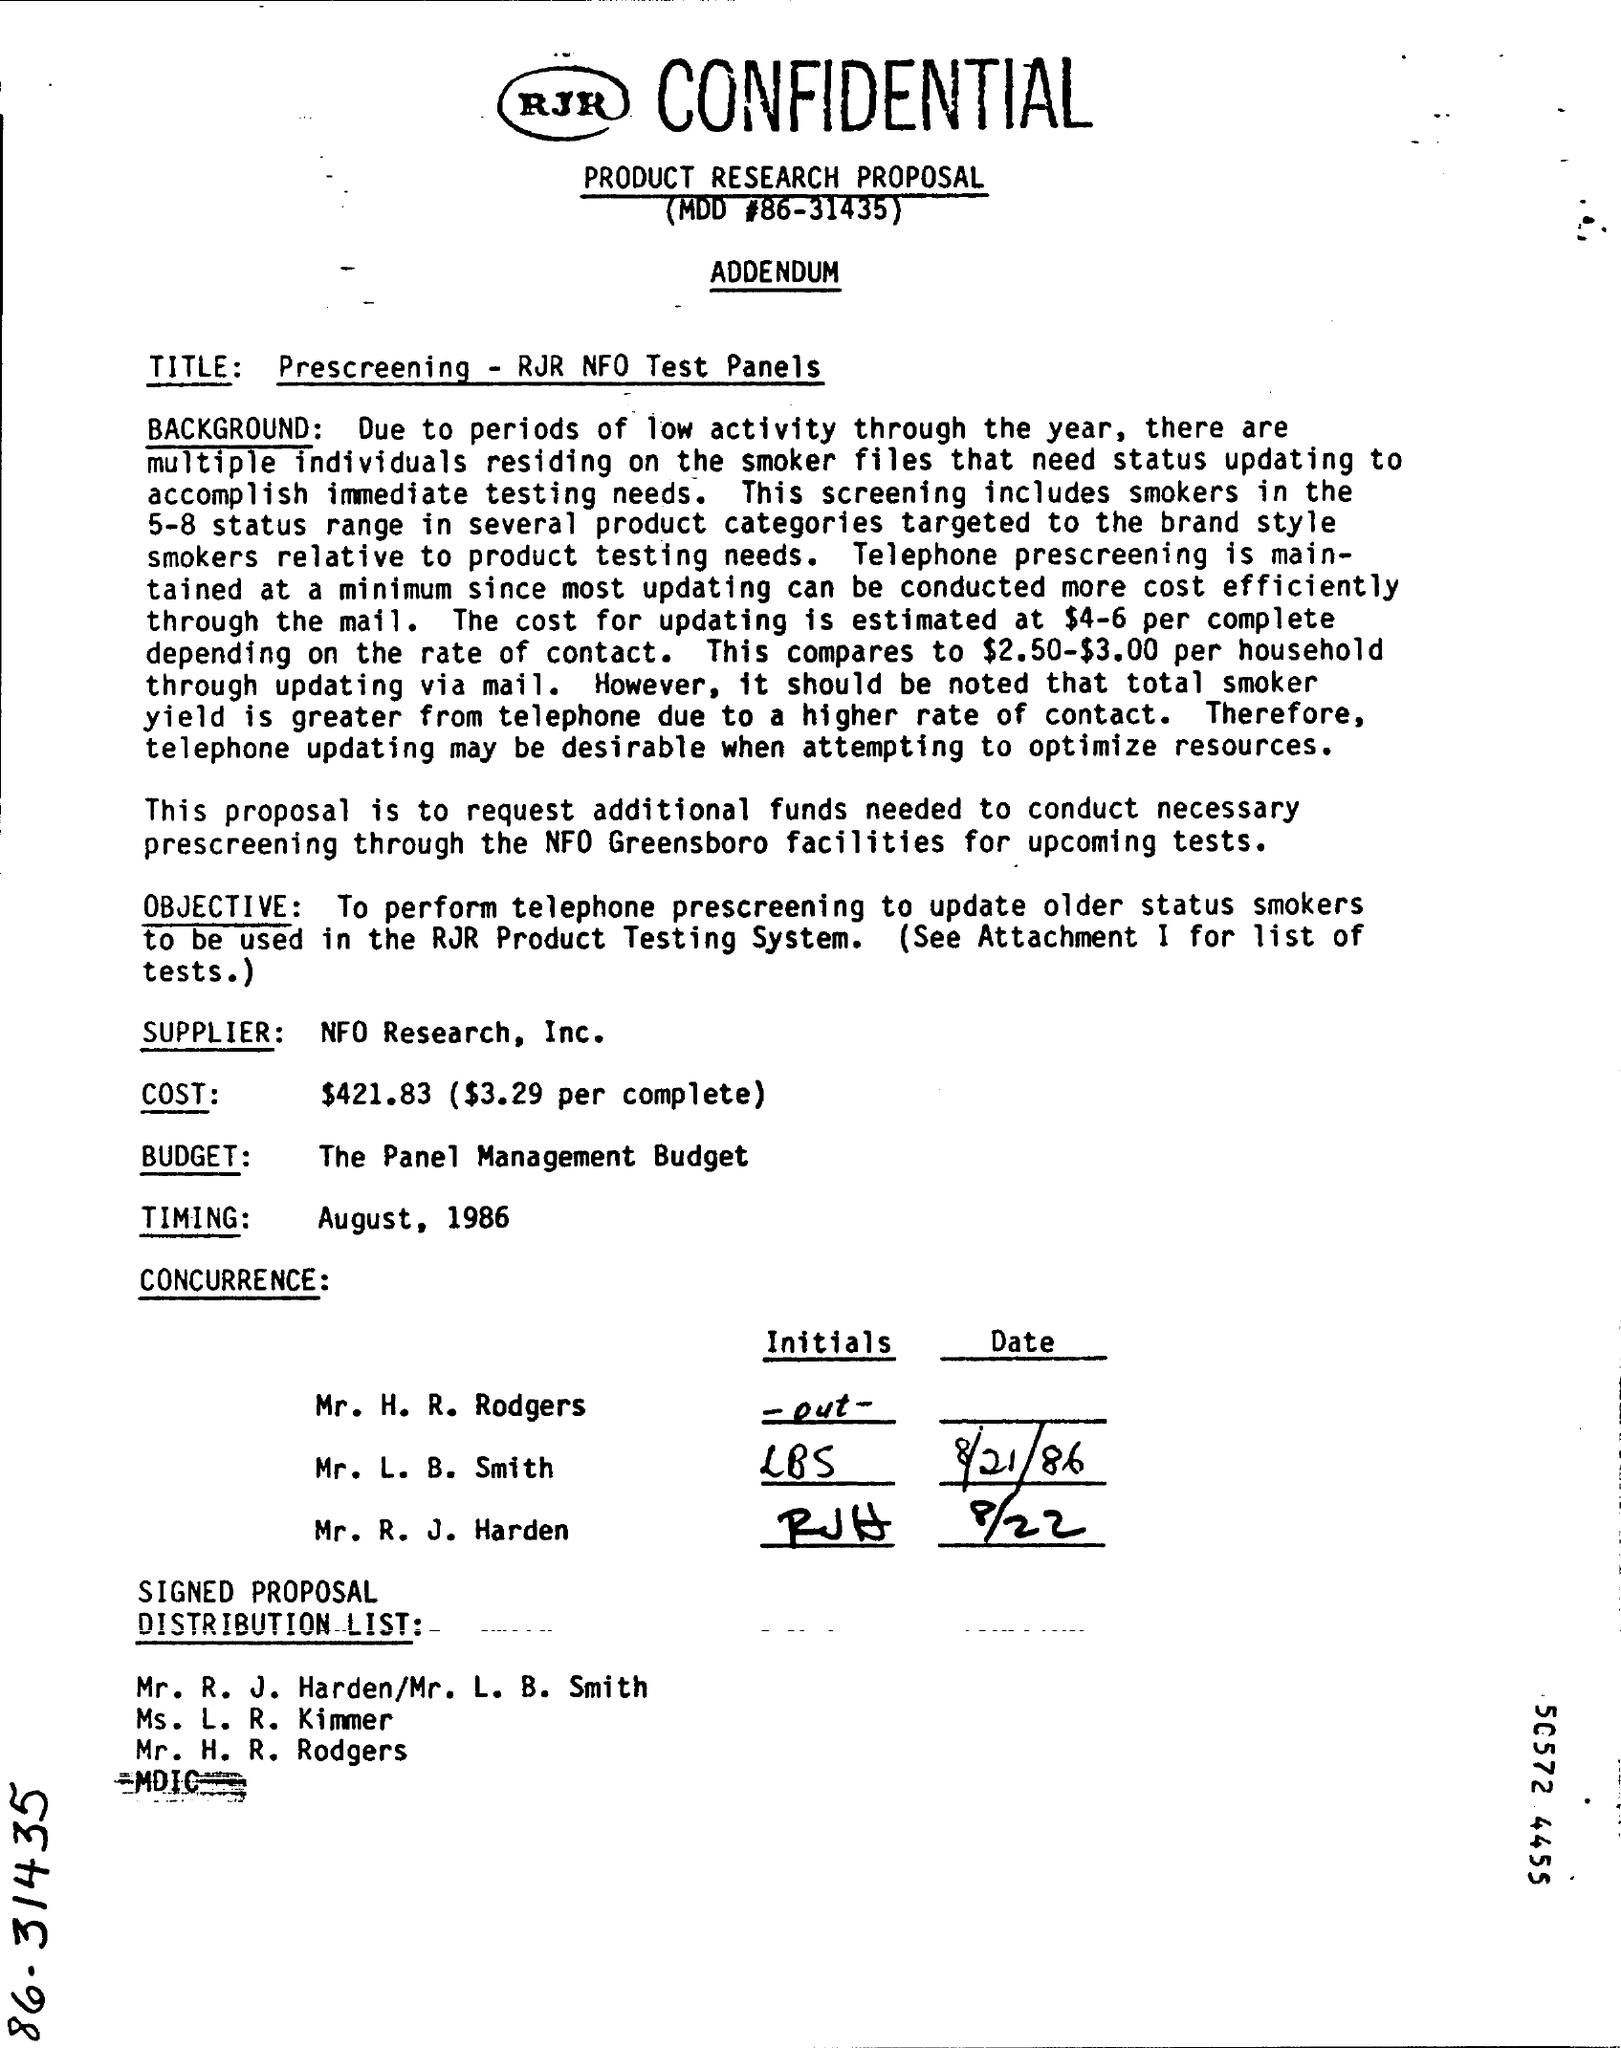What is the estimated cost depending on rate of contact?
Provide a succinct answer. $4-6. How much per household can cost updating through mails?
Offer a terse response. $2.50-$3.00. 